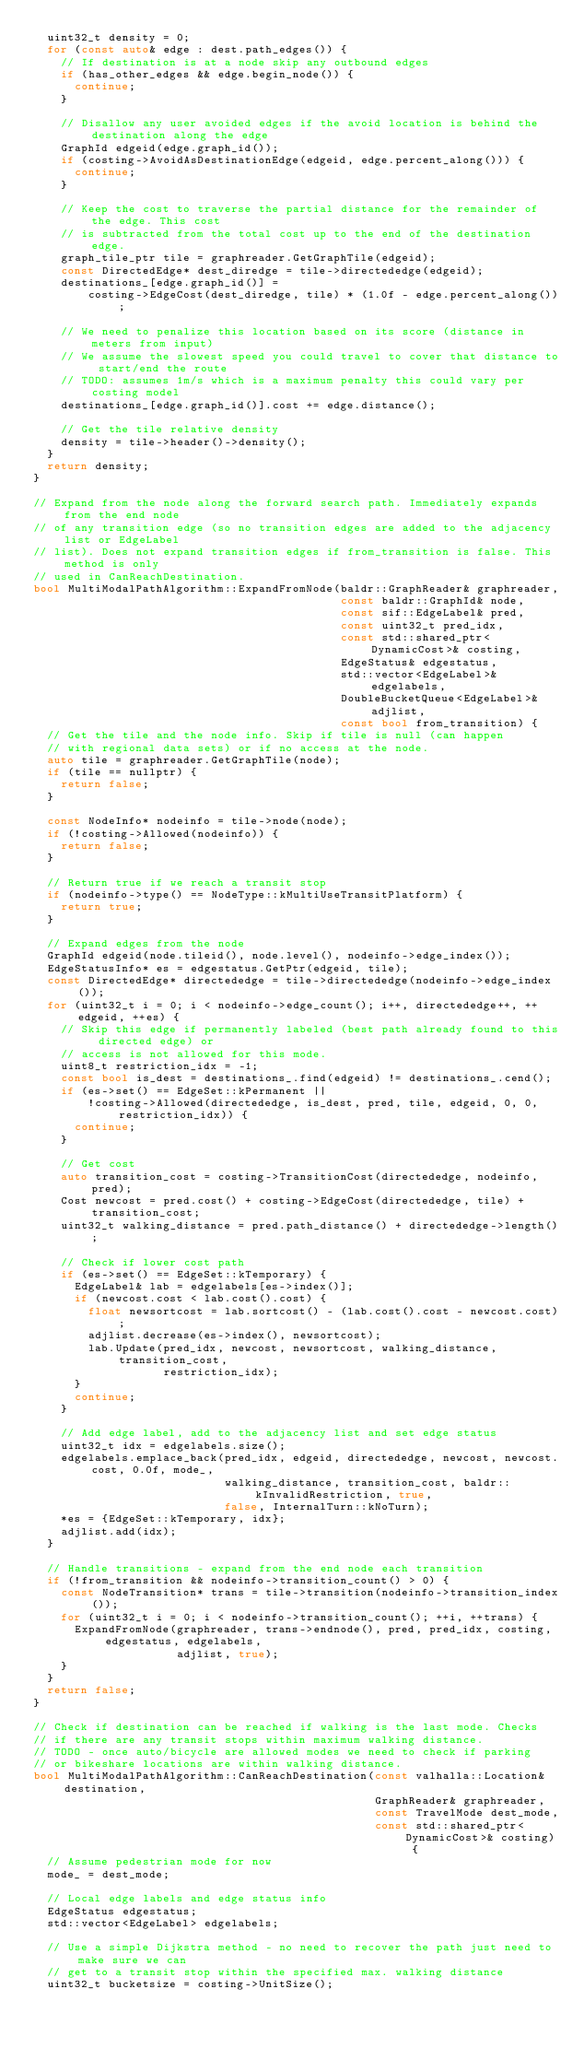Convert code to text. <code><loc_0><loc_0><loc_500><loc_500><_C++_>  uint32_t density = 0;
  for (const auto& edge : dest.path_edges()) {
    // If destination is at a node skip any outbound edges
    if (has_other_edges && edge.begin_node()) {
      continue;
    }

    // Disallow any user avoided edges if the avoid location is behind the destination along the edge
    GraphId edgeid(edge.graph_id());
    if (costing->AvoidAsDestinationEdge(edgeid, edge.percent_along())) {
      continue;
    }

    // Keep the cost to traverse the partial distance for the remainder of the edge. This cost
    // is subtracted from the total cost up to the end of the destination edge.
    graph_tile_ptr tile = graphreader.GetGraphTile(edgeid);
    const DirectedEdge* dest_diredge = tile->directededge(edgeid);
    destinations_[edge.graph_id()] =
        costing->EdgeCost(dest_diredge, tile) * (1.0f - edge.percent_along());

    // We need to penalize this location based on its score (distance in meters from input)
    // We assume the slowest speed you could travel to cover that distance to start/end the route
    // TODO: assumes 1m/s which is a maximum penalty this could vary per costing model
    destinations_[edge.graph_id()].cost += edge.distance();

    // Get the tile relative density
    density = tile->header()->density();
  }
  return density;
}

// Expand from the node along the forward search path. Immediately expands from the end node
// of any transition edge (so no transition edges are added to the adjacency list or EdgeLabel
// list). Does not expand transition edges if from_transition is false. This method is only
// used in CanReachDestination.
bool MultiModalPathAlgorithm::ExpandFromNode(baldr::GraphReader& graphreader,
                                             const baldr::GraphId& node,
                                             const sif::EdgeLabel& pred,
                                             const uint32_t pred_idx,
                                             const std::shared_ptr<DynamicCost>& costing,
                                             EdgeStatus& edgestatus,
                                             std::vector<EdgeLabel>& edgelabels,
                                             DoubleBucketQueue<EdgeLabel>& adjlist,
                                             const bool from_transition) {
  // Get the tile and the node info. Skip if tile is null (can happen
  // with regional data sets) or if no access at the node.
  auto tile = graphreader.GetGraphTile(node);
  if (tile == nullptr) {
    return false;
  }

  const NodeInfo* nodeinfo = tile->node(node);
  if (!costing->Allowed(nodeinfo)) {
    return false;
  }

  // Return true if we reach a transit stop
  if (nodeinfo->type() == NodeType::kMultiUseTransitPlatform) {
    return true;
  }

  // Expand edges from the node
  GraphId edgeid(node.tileid(), node.level(), nodeinfo->edge_index());
  EdgeStatusInfo* es = edgestatus.GetPtr(edgeid, tile);
  const DirectedEdge* directededge = tile->directededge(nodeinfo->edge_index());
  for (uint32_t i = 0; i < nodeinfo->edge_count(); i++, directededge++, ++edgeid, ++es) {
    // Skip this edge if permanently labeled (best path already found to this directed edge) or
    // access is not allowed for this mode.
    uint8_t restriction_idx = -1;
    const bool is_dest = destinations_.find(edgeid) != destinations_.cend();
    if (es->set() == EdgeSet::kPermanent ||
        !costing->Allowed(directededge, is_dest, pred, tile, edgeid, 0, 0, restriction_idx)) {
      continue;
    }

    // Get cost
    auto transition_cost = costing->TransitionCost(directededge, nodeinfo, pred);
    Cost newcost = pred.cost() + costing->EdgeCost(directededge, tile) + transition_cost;
    uint32_t walking_distance = pred.path_distance() + directededge->length();

    // Check if lower cost path
    if (es->set() == EdgeSet::kTemporary) {
      EdgeLabel& lab = edgelabels[es->index()];
      if (newcost.cost < lab.cost().cost) {
        float newsortcost = lab.sortcost() - (lab.cost().cost - newcost.cost);
        adjlist.decrease(es->index(), newsortcost);
        lab.Update(pred_idx, newcost, newsortcost, walking_distance, transition_cost,
                   restriction_idx);
      }
      continue;
    }

    // Add edge label, add to the adjacency list and set edge status
    uint32_t idx = edgelabels.size();
    edgelabels.emplace_back(pred_idx, edgeid, directededge, newcost, newcost.cost, 0.0f, mode_,
                            walking_distance, transition_cost, baldr::kInvalidRestriction, true,
                            false, InternalTurn::kNoTurn);
    *es = {EdgeSet::kTemporary, idx};
    adjlist.add(idx);
  }

  // Handle transitions - expand from the end node each transition
  if (!from_transition && nodeinfo->transition_count() > 0) {
    const NodeTransition* trans = tile->transition(nodeinfo->transition_index());
    for (uint32_t i = 0; i < nodeinfo->transition_count(); ++i, ++trans) {
      ExpandFromNode(graphreader, trans->endnode(), pred, pred_idx, costing, edgestatus, edgelabels,
                     adjlist, true);
    }
  }
  return false;
}

// Check if destination can be reached if walking is the last mode. Checks
// if there are any transit stops within maximum walking distance.
// TODO - once auto/bicycle are allowed modes we need to check if parking
// or bikeshare locations are within walking distance.
bool MultiModalPathAlgorithm::CanReachDestination(const valhalla::Location& destination,
                                                  GraphReader& graphreader,
                                                  const TravelMode dest_mode,
                                                  const std::shared_ptr<DynamicCost>& costing) {
  // Assume pedestrian mode for now
  mode_ = dest_mode;

  // Local edge labels and edge status info
  EdgeStatus edgestatus;
  std::vector<EdgeLabel> edgelabels;

  // Use a simple Dijkstra method - no need to recover the path just need to make sure we can
  // get to a transit stop within the specified max. walking distance
  uint32_t bucketsize = costing->UnitSize();</code> 